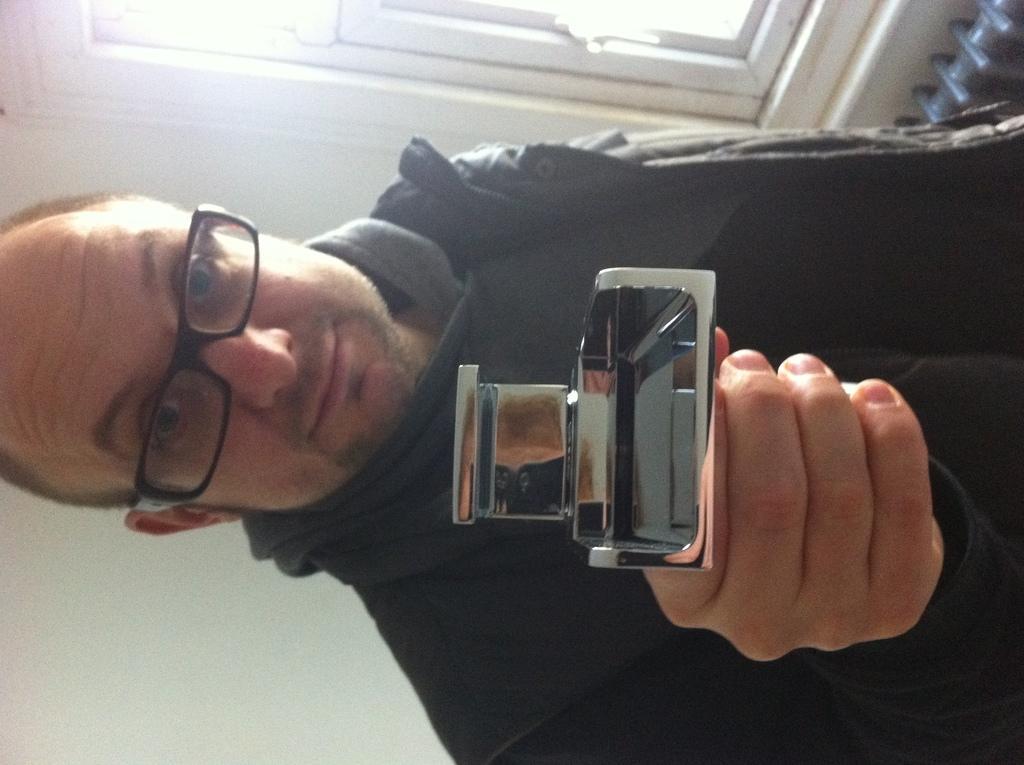How would you summarize this image in a sentence or two? In this image I can see the person and the person is holding some object. Background I can see the window and the wall is in white color. 